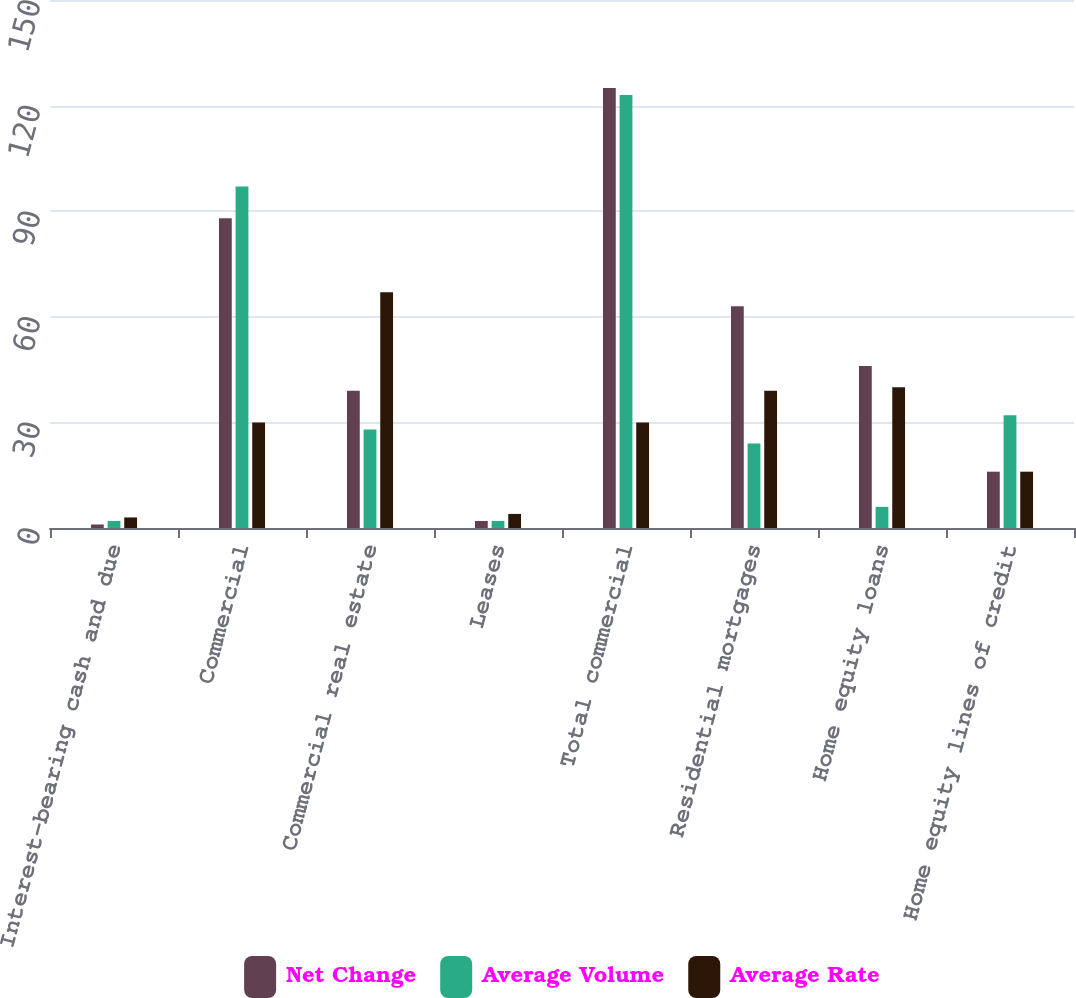<chart> <loc_0><loc_0><loc_500><loc_500><stacked_bar_chart><ecel><fcel>Interest-bearing cash and due<fcel>Commercial<fcel>Commercial real estate<fcel>Leases<fcel>Total commercial<fcel>Residential mortgages<fcel>Home equity loans<fcel>Home equity lines of credit<nl><fcel>Net Change<fcel>1<fcel>88<fcel>39<fcel>2<fcel>125<fcel>63<fcel>46<fcel>16<nl><fcel>Average Volume<fcel>2<fcel>97<fcel>28<fcel>2<fcel>123<fcel>24<fcel>6<fcel>32<nl><fcel>Average Rate<fcel>3<fcel>30<fcel>67<fcel>4<fcel>30<fcel>39<fcel>40<fcel>16<nl></chart> 